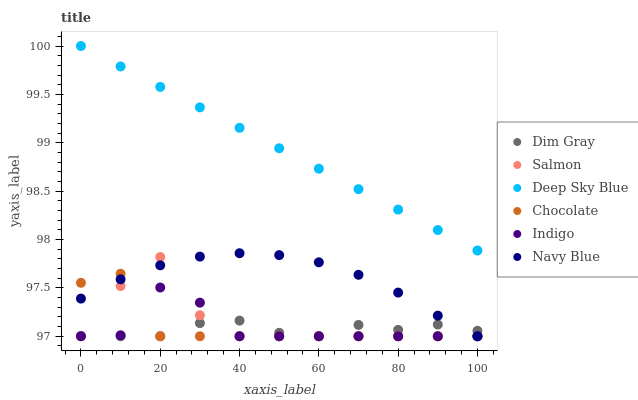Does Dim Gray have the minimum area under the curve?
Answer yes or no. Yes. Does Deep Sky Blue have the maximum area under the curve?
Answer yes or no. Yes. Does Indigo have the minimum area under the curve?
Answer yes or no. No. Does Indigo have the maximum area under the curve?
Answer yes or no. No. Is Deep Sky Blue the smoothest?
Answer yes or no. Yes. Is Salmon the roughest?
Answer yes or no. Yes. Is Indigo the smoothest?
Answer yes or no. No. Is Indigo the roughest?
Answer yes or no. No. Does Dim Gray have the lowest value?
Answer yes or no. Yes. Does Deep Sky Blue have the lowest value?
Answer yes or no. No. Does Deep Sky Blue have the highest value?
Answer yes or no. Yes. Does Indigo have the highest value?
Answer yes or no. No. Is Dim Gray less than Deep Sky Blue?
Answer yes or no. Yes. Is Deep Sky Blue greater than Chocolate?
Answer yes or no. Yes. Does Dim Gray intersect Salmon?
Answer yes or no. Yes. Is Dim Gray less than Salmon?
Answer yes or no. No. Is Dim Gray greater than Salmon?
Answer yes or no. No. Does Dim Gray intersect Deep Sky Blue?
Answer yes or no. No. 